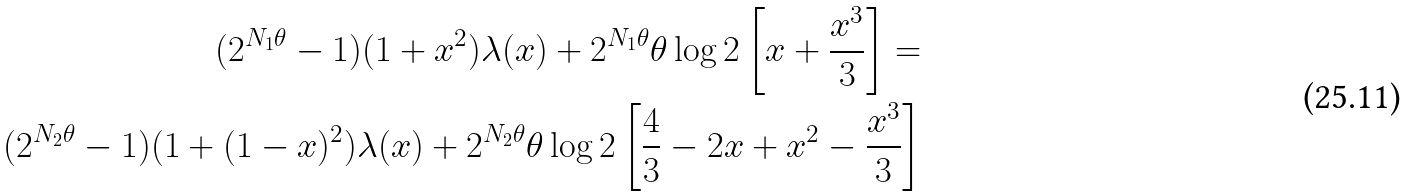Convert formula to latex. <formula><loc_0><loc_0><loc_500><loc_500>( 2 ^ { N _ { 1 } \theta } - 1 ) ( 1 + x ^ { 2 } ) \lambda ( x ) + 2 ^ { N _ { 1 } \theta } \theta \log 2 \left [ x + \frac { x ^ { 3 } } { 3 } \right ] = \\ ( 2 ^ { N _ { 2 } \theta } - 1 ) ( 1 + ( 1 - x ) ^ { 2 } ) \lambda ( x ) + 2 ^ { N _ { 2 } \theta } \theta \log 2 \left [ \frac { 4 } { 3 } - 2 x + x ^ { 2 } - \frac { x ^ { 3 } } { 3 } \right ]</formula> 